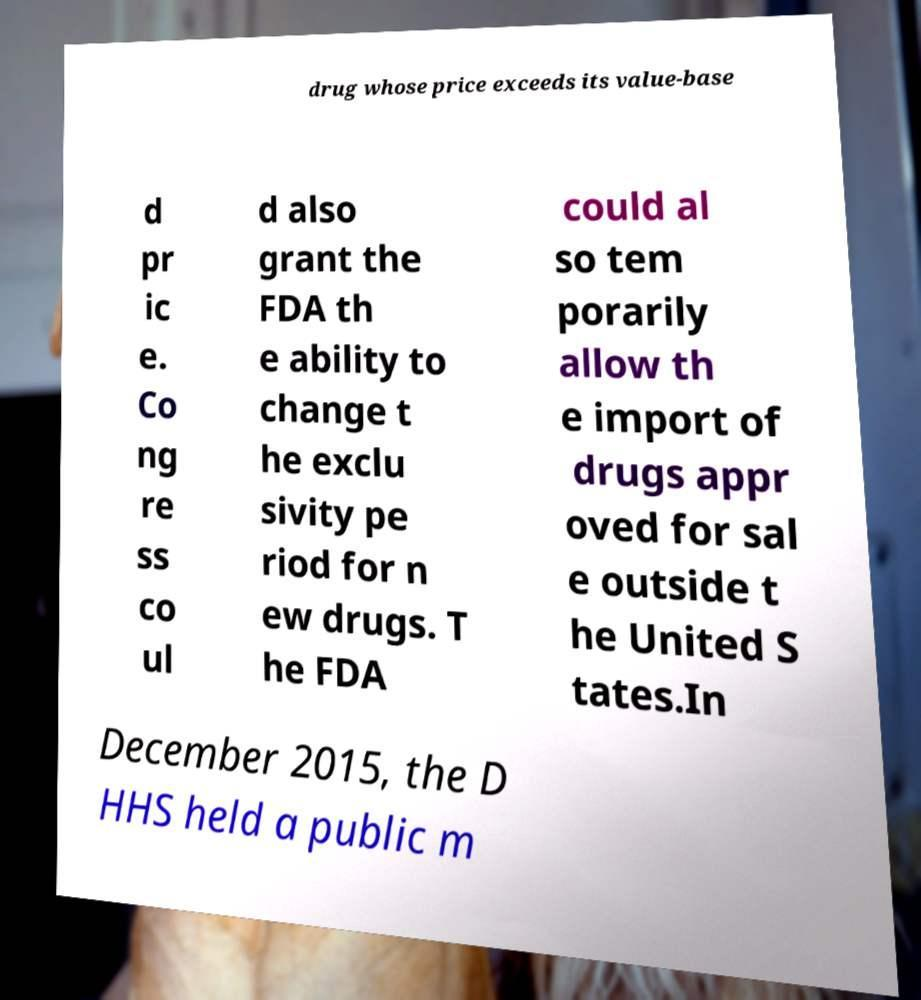There's text embedded in this image that I need extracted. Can you transcribe it verbatim? drug whose price exceeds its value-base d pr ic e. Co ng re ss co ul d also grant the FDA th e ability to change t he exclu sivity pe riod for n ew drugs. T he FDA could al so tem porarily allow th e import of drugs appr oved for sal e outside t he United S tates.In December 2015, the D HHS held a public m 